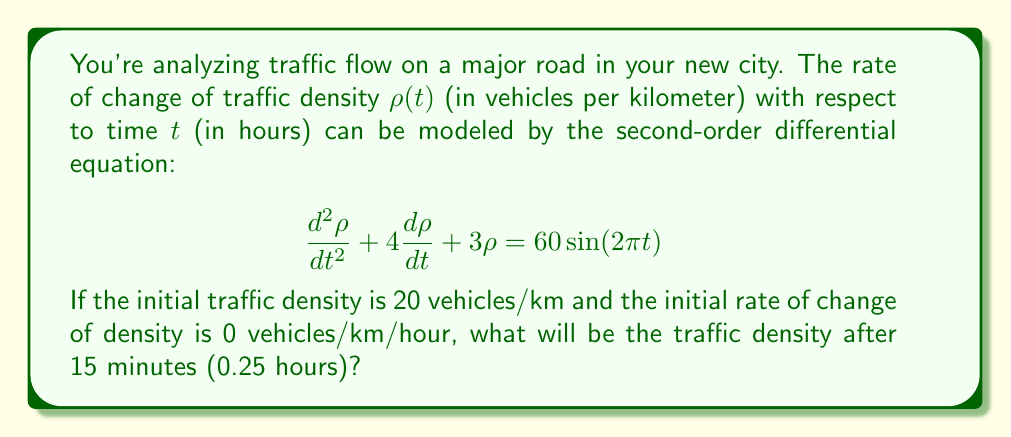What is the answer to this math problem? To solve this problem, we need to find the general solution to the differential equation and then apply the initial conditions.

1) The homogeneous solution:
   The characteristic equation is $r^2 + 4r + 3 = 0$
   Solving this: $r = -1$ or $r = -3$
   So the homogeneous solution is: $\rho_h(t) = c_1e^{-t} + c_2e^{-3t}$

2) The particular solution:
   We guess a solution of the form $\rho_p(t) = A\sin(2\pi t) + B\cos(2\pi t)$
   Substituting this into the original equation and solving for A and B:
   $A = 3$ and $B = -2$
   So $\rho_p(t) = 3\sin(2\pi t) - 2\cos(2\pi t)$

3) The general solution:
   $\rho(t) = c_1e^{-t} + c_2e^{-3t} + 3\sin(2\pi t) - 2\cos(2\pi t)$

4) Apply initial conditions:
   $\rho(0) = 20$, so $c_1 + c_2 - 2 = 20$
   $\rho'(0) = 0$, so $-c_1 - 3c_2 + 6\pi = 0$

   Solving these simultaneously:
   $c_1 = 18$ and $c_2 = 4$

5) The final solution:
   $\rho(t) = 18e^{-t} + 4e^{-3t} + 3\sin(2\pi t) - 2\cos(2\pi t)$

6) Evaluate at t = 0.25:
   $\rho(0.25) = 18e^{-0.25} + 4e^{-0.75} + 3\sin(0.5\pi) - 2\cos(0.5\pi)$
               $\approx 15.63 + 1.89 + 3 - (-1.41)$
               $\approx 21.93$
Answer: The traffic density after 15 minutes (0.25 hours) will be approximately 21.93 vehicles/km. 